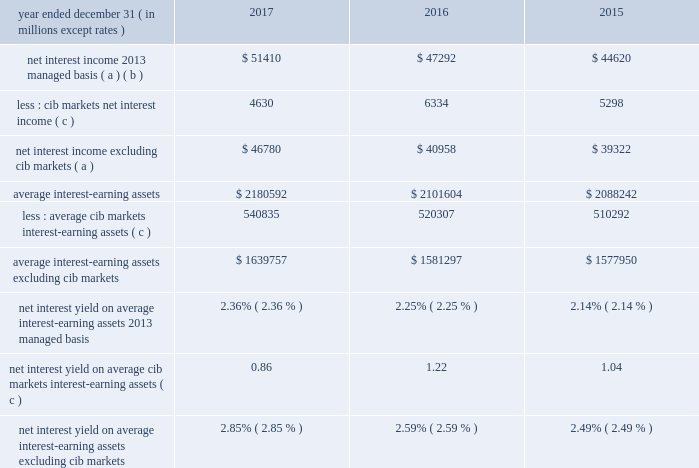Jpmorgan chase & co./2017 annual report 53 net interest income excluding cib 2019s markets businesses in addition to reviewing net interest income on a managed basis , management also reviews net interest income excluding net interest income arising from cib 2019s markets businesses to assess the performance of the firm 2019s lending , investing ( including asset-liability management ) and deposit-raising activities .
This net interest income is referred to as non-markets related net interest income .
Cib 2019s markets businesses are fixed income markets and equity markets .
Management believes that disclosure of non-markets related net interest income provides investors and analysts with another measure by which to analyze the non-markets-related business trends of the firm and provides a comparable measure to other financial institutions that are primarily focused on lending , investing and deposit-raising activities .
The data presented below are non-gaap financial measures due to the exclusion of markets related net interest income arising from cib .
Year ended december 31 , ( in millions , except rates ) 2017 2016 2015 net interest income 2013 managed basis ( a ) ( b ) $ 51410 $ 47292 $ 44620 less : cib markets net interest income ( c ) 4630 6334 5298 net interest income excluding cib markets ( a ) $ 46780 $ 40958 $ 39322 average interest-earning assets $ 2180592 $ 2101604 $ 2088242 less : average cib markets interest-earning assets ( c ) 540835 520307 510292 average interest-earning assets excluding cib markets $ 1639757 $ 1581297 $ 1577950 net interest yield on average interest-earning assets 2013 managed basis 2.36% ( 2.36 % ) 2.25% ( 2.25 % ) 2.14% ( 2.14 % ) net interest yield on average cib markets interest-earning assets ( c ) 0.86 1.22 1.04 net interest yield on average interest-earning assets excluding cib markets 2.85% ( 2.85 % ) 2.59% ( 2.59 % ) 2.49% ( 2.49 % ) ( a ) interest includes the effect of related hedges .
Taxable-equivalent amounts are used where applicable .
( b ) for a reconciliation of net interest income on a reported and managed basis , see reconciliation from the firm 2019s reported u.s .
Gaap results to managed basis on page 52 .
( c ) the amounts in this table differ from the prior-period presentation to align with cib 2019s markets businesses .
For further information on cib 2019s markets businesses , see page 65 .
Calculation of certain u.s .
Gaap and non-gaap financial measures certain u.s .
Gaap and non-gaap financial measures are calculated as follows : book value per share ( 201cbvps 201d ) common stockholders 2019 equity at period-end / common shares at period-end overhead ratio total noninterest expense / total net revenue return on assets ( 201croa 201d ) reported net income / total average assets return on common equity ( 201croe 201d ) net income* / average common stockholders 2019 equity return on tangible common equity ( 201crotce 201d ) net income* / average tangible common equity tangible book value per share ( 201ctbvps 201d ) tangible common equity at period-end / common shares at period-end * represents net income applicable to common equity .
Jpmorgan chase & co./2017 annual report 53 net interest income excluding cib 2019s markets businesses in addition to reviewing net interest income on a managed basis , management also reviews net interest income excluding net interest income arising from cib 2019s markets businesses to assess the performance of the firm 2019s lending , investing ( including asset-liability management ) and deposit-raising activities .
This net interest income is referred to as non-markets related net interest income .
Cib 2019s markets businesses are fixed income markets and equity markets .
Management believes that disclosure of non-markets related net interest income provides investors and analysts with another measure by which to analyze the non-markets-related business trends of the firm and provides a comparable measure to other financial institutions that are primarily focused on lending , investing and deposit-raising activities .
The data presented below are non-gaap financial measures due to the exclusion of markets related net interest income arising from cib .
Year ended december 31 , ( in millions , except rates ) 2017 2016 2015 net interest income 2013 managed basis ( a ) ( b ) $ 51410 $ 47292 $ 44620 less : cib markets net interest income ( c ) 4630 6334 5298 net interest income excluding cib markets ( a ) $ 46780 $ 40958 $ 39322 average interest-earning assets $ 2180592 $ 2101604 $ 2088242 less : average cib markets interest-earning assets ( c ) 540835 520307 510292 average interest-earning assets excluding cib markets $ 1639757 $ 1581297 $ 1577950 net interest yield on average interest-earning assets 2013 managed basis 2.36% ( 2.36 % ) 2.25% ( 2.25 % ) 2.14% ( 2.14 % ) net interest yield on average cib markets interest-earning assets ( c ) 0.86 1.22 1.04 net interest yield on average interest-earning assets excluding cib markets 2.85% ( 2.85 % ) 2.59% ( 2.59 % ) 2.49% ( 2.49 % ) ( a ) interest includes the effect of related hedges .
Taxable-equivalent amounts are used where applicable .
( b ) for a reconciliation of net interest income on a reported and managed basis , see reconciliation from the firm 2019s reported u.s .
Gaap results to managed basis on page 52 .
( c ) the amounts in this table differ from the prior-period presentation to align with cib 2019s markets businesses .
For further information on cib 2019s markets businesses , see page 65 .
Calculation of certain u.s .
Gaap and non-gaap financial measures certain u.s .
Gaap and non-gaap financial measures are calculated as follows : book value per share ( 201cbvps 201d ) common stockholders 2019 equity at period-end / common shares at period-end overhead ratio total noninterest expense / total net revenue return on assets ( 201croa 201d ) reported net income / total average assets return on common equity ( 201croe 201d ) net income* / average common stockholders 2019 equity return on tangible common equity ( 201crotce 201d ) net income* / average tangible common equity tangible book value per share ( 201ctbvps 201d ) tangible common equity at period-end / common shares at period-end * represents net income applicable to common equity .
What was the percentage change in the average interest-earning assets excluding cib markets in 2017? 
Computations: ((1639757 - 1581297) / 1581297)
Answer: 0.03697. 